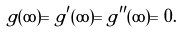Convert formula to latex. <formula><loc_0><loc_0><loc_500><loc_500>g ( \infty ) = g ^ { \prime } ( \infty ) = g ^ { \prime \prime } ( \infty ) = 0 .</formula> 